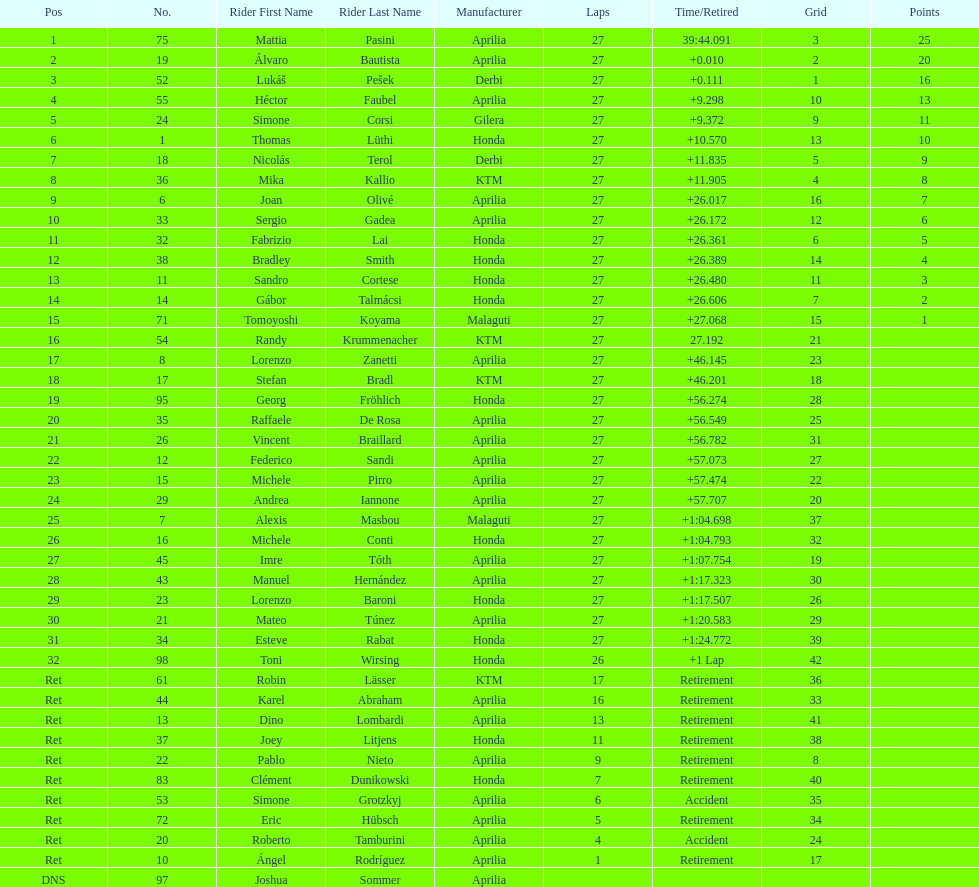Out of all the people who have points, who has the least? Tomoyoshi Koyama. 